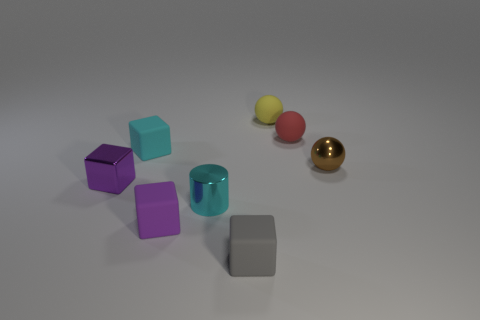How many objects are either small red matte spheres or big yellow objects?
Keep it short and to the point. 1. What is the size of the metal thing that is on the right side of the tiny cyan metal object?
Keep it short and to the point. Small. Is there anything else that is the same size as the metallic cube?
Provide a succinct answer. Yes. The block that is on the left side of the gray matte object and in front of the tiny purple metal object is what color?
Provide a succinct answer. Purple. Does the small block to the right of the tiny cyan shiny object have the same material as the small cyan cylinder?
Give a very brief answer. No. There is a tiny metallic sphere; is its color the same as the rubber thing on the right side of the tiny yellow object?
Offer a terse response. No. Are there any small objects in front of the yellow object?
Your response must be concise. Yes. There is a sphere in front of the tiny red rubber thing; does it have the same size as the rubber sphere that is left of the red rubber sphere?
Give a very brief answer. Yes. Is there another brown metal thing of the same size as the brown thing?
Provide a short and direct response. No. Is the shape of the purple thing in front of the tiny metallic cube the same as  the tiny cyan shiny thing?
Offer a terse response. No. 